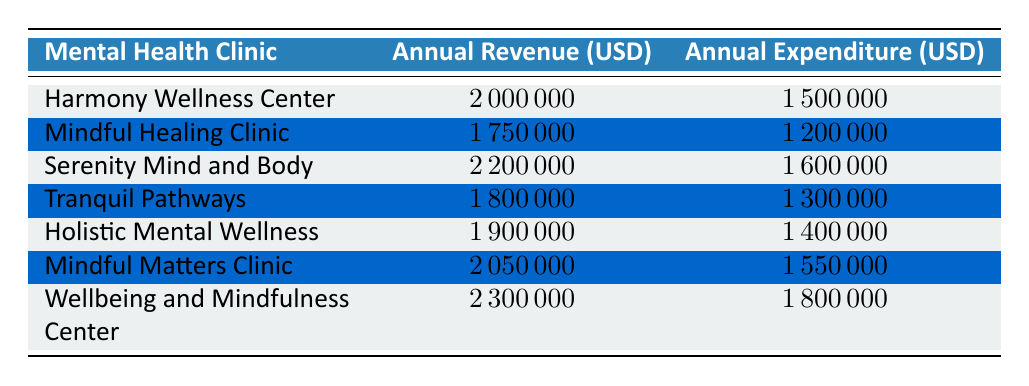What is the annual revenue of the Wellbeing and Mindfulness Center? The annual revenue of the Wellbeing and Mindfulness Center is listed in the table as 2300000 USD.
Answer: 2300000 Which clinic has the highest annual expenditure? The clinic with the highest annual expenditure is Wellbeing and Mindfulness Center, with an expenditure of 1800000 USD, which is greater than that of the other clinics listed.
Answer: Wellbeing and Mindfulness Center What is the difference between the annual revenues of Serenity Mind and Body and Mindful Healing Clinic? The annual revenue of Serenity Mind and Body is 2200000 USD and that of Mindful Healing Clinic is 1750000 USD. The difference is 2200000 - 1750000 = 450000 USD.
Answer: 450000 What is the average annual revenue of all clinics listed? To find the average annual revenue, first, sum the revenues: (2000000 + 1750000 + 2200000 + 1800000 + 1900000 + 2050000 + 2300000) = 14000000. Then divide by the number of clinics (7): 14000000 / 7 = 2000000 USD.
Answer: 2000000 Is the annual expenditure of Mindful Matters Clinic less than 1600000 USD? The annual expenditure of Mindful Matters Clinic is listed as 1550000 USD, which is indeed less than 1600000 USD.
Answer: Yes What is the total annual revenue of all clinics combined? The total annual revenue can be calculated by summing all the individual revenues: (2000000 + 1750000 + 2200000 + 1800000 + 1900000 + 2050000 + 2300000) = 14000000 USD.
Answer: 14000000 Which clinic has the lowest annual revenue, and what is that revenue? Mindful Healing Clinic has the lowest annual revenue of the listed clinics, which is 1750000 USD.
Answer: Mindful Healing Clinic, 1750000 If we take the clinic with the highest revenue and the one with the lowest revenue, what is their combined revenue? The clinic with the highest revenue is Wellbeing and Mindfulness Center at 2300000 USD, while the lowest is Mindful Healing Clinic at 1750000 USD. Their combined revenue is 2300000 + 1750000 = 4050000 USD.
Answer: 4050000 